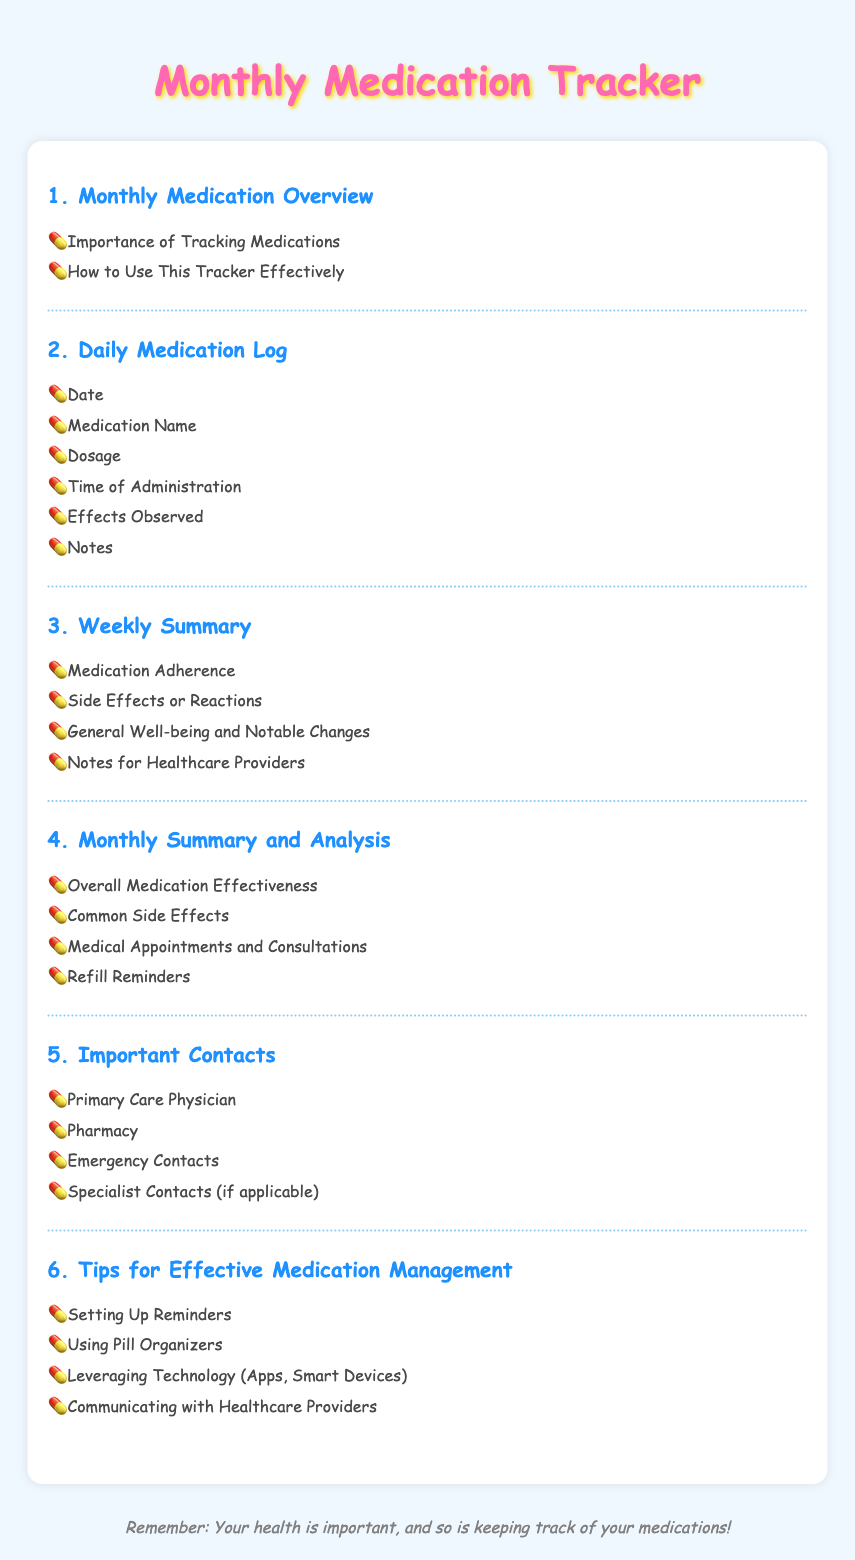What is the title of the document? The document is titled "Monthly Medication Tracker" as indicated in the header.
Answer: Monthly Medication Tracker How many sections are there in the Table of Contents? There are six sections listed in the Table of Contents.
Answer: 6 What is the first item in the "Daily Medication Log" section? The first item mentioned in the Daily Medication Log section is "Date."
Answer: Date What does the "Weekly Summary" section include? The "Weekly Summary" section includes "Medication Adherence," "Side Effects or Reactions," "General Well-being and Notable Changes," and "Notes for Healthcare Providers."
Answer: Medication Adherence, Side Effects or Reactions, General Well-being and Notable Changes, Notes for Healthcare Providers What is the last item in the "Important Contacts" section? The last item in the Important Contacts section is "Specialist Contacts (if applicable)."
Answer: Specialist Contacts (if applicable) What reminder is mentioned in the "Monthly Summary and Analysis" section? The reminder mentioned in the section is "Refill Reminders."
Answer: Refill Reminders 